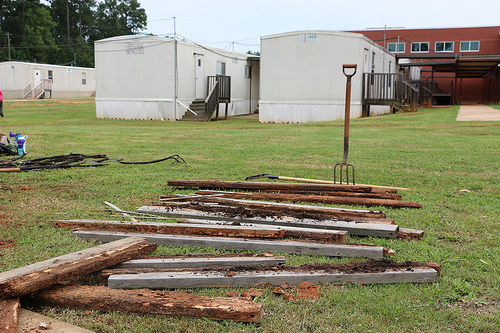<image>
Is there a pitchfork on the grass? Yes. Looking at the image, I can see the pitchfork is positioned on top of the grass, with the grass providing support. 